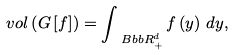<formula> <loc_0><loc_0><loc_500><loc_500>v o l \left ( G \left [ f \right ] \right ) = \int _ { \ B b b { R } _ { + } ^ { d } } f \left ( y \right ) \, d y ,</formula> 